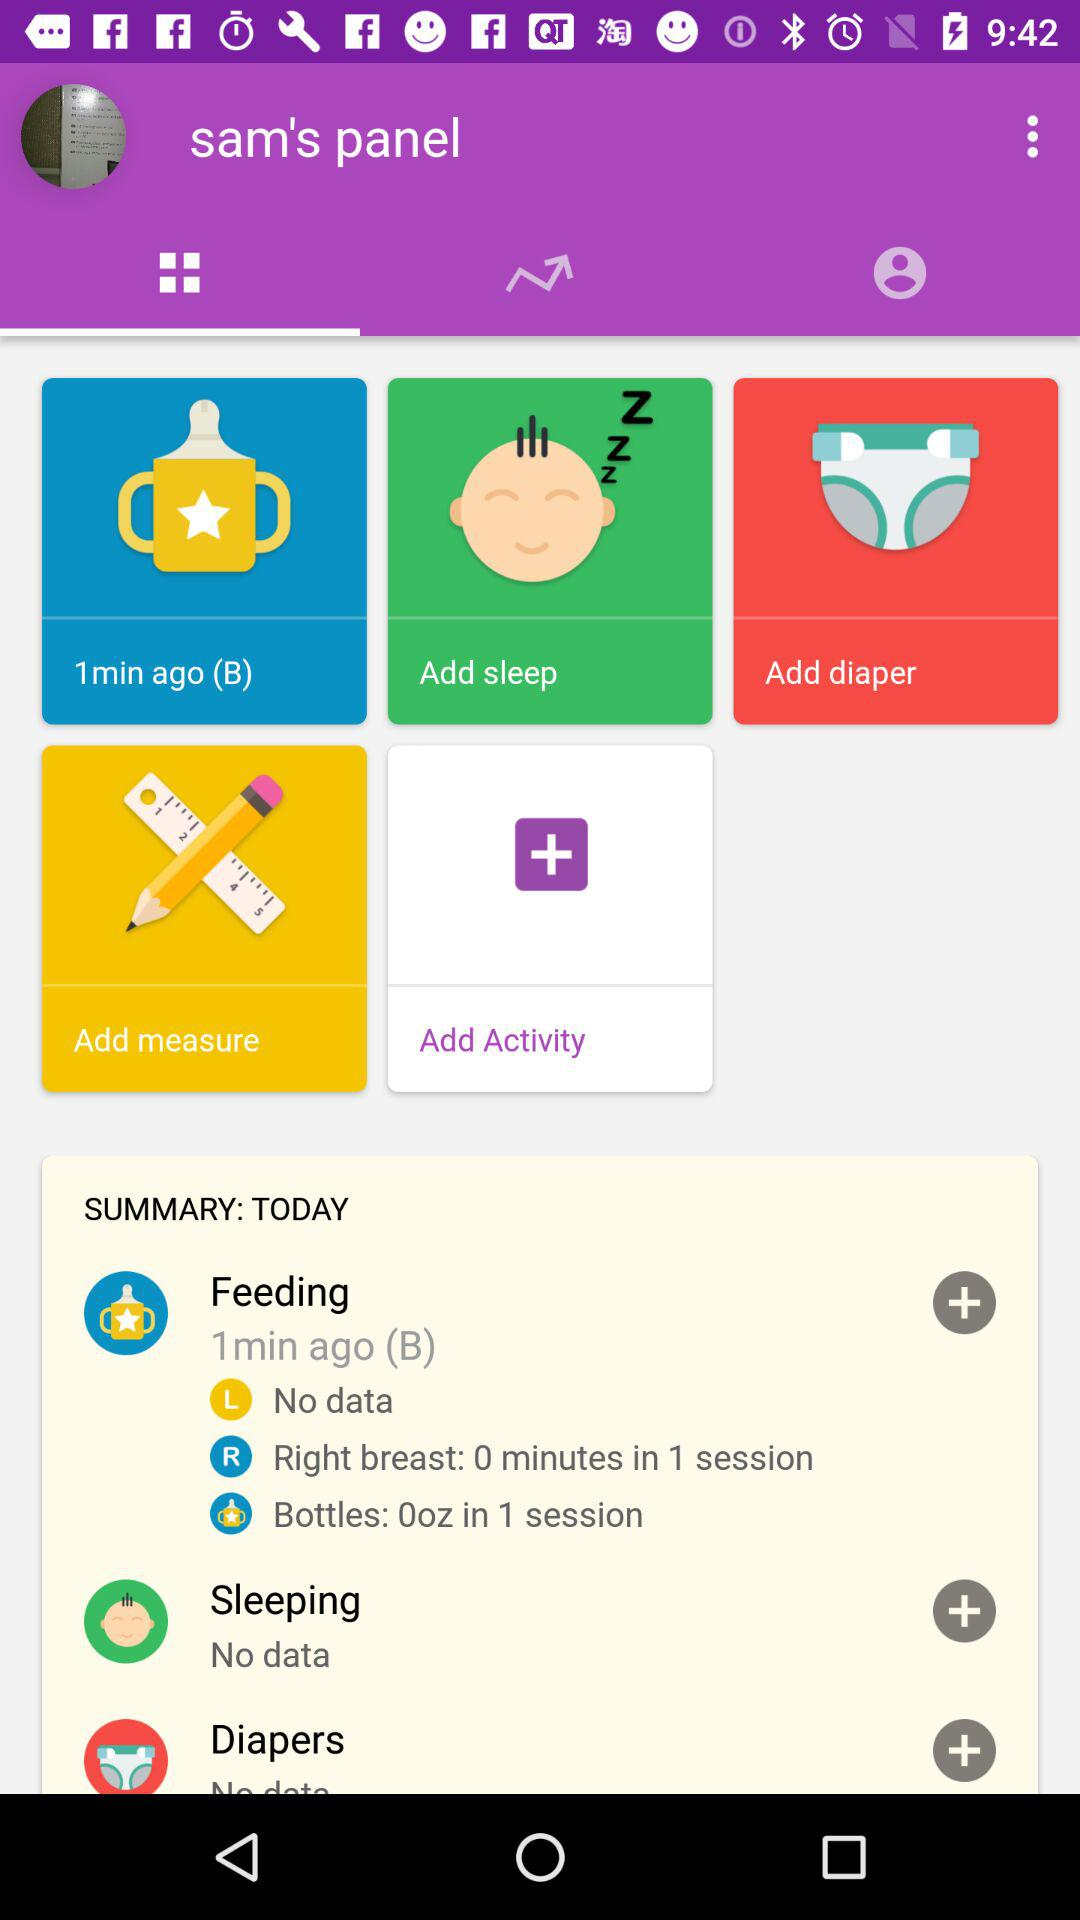What is the volume of milk in the bottle in 1 session? The volume of milk in the bottle in 1 session is 0 oz. 